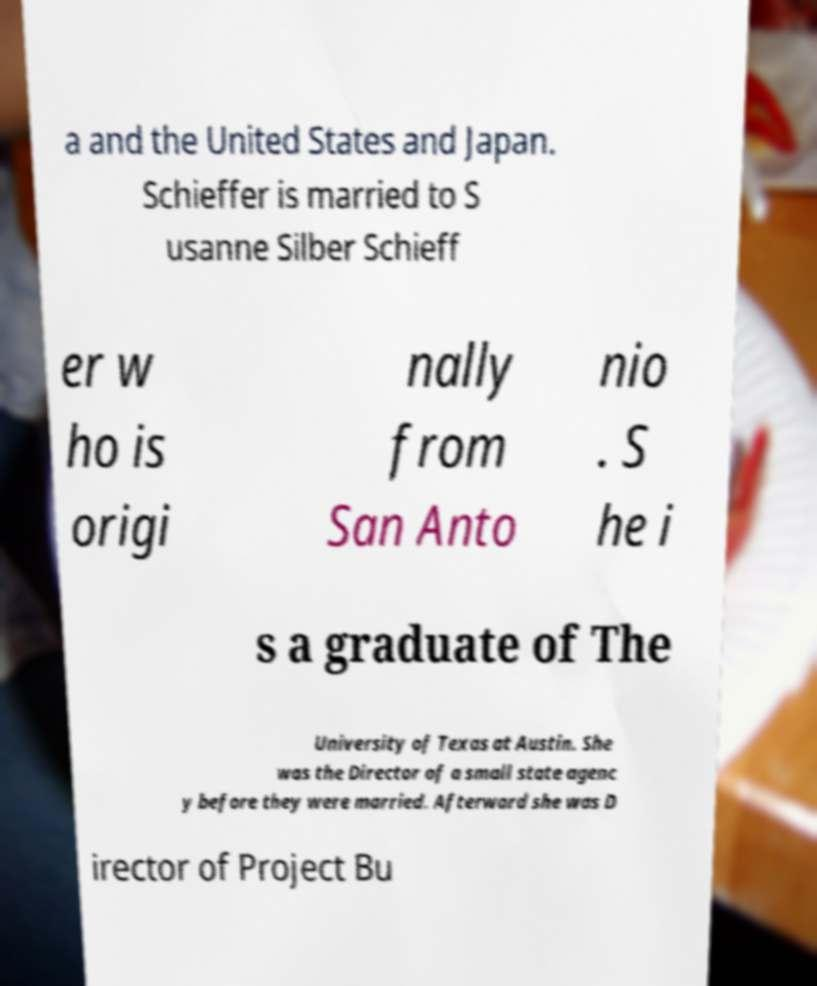Could you assist in decoding the text presented in this image and type it out clearly? a and the United States and Japan. Schieffer is married to S usanne Silber Schieff er w ho is origi nally from San Anto nio . S he i s a graduate of The University of Texas at Austin. She was the Director of a small state agenc y before they were married. Afterward she was D irector of Project Bu 